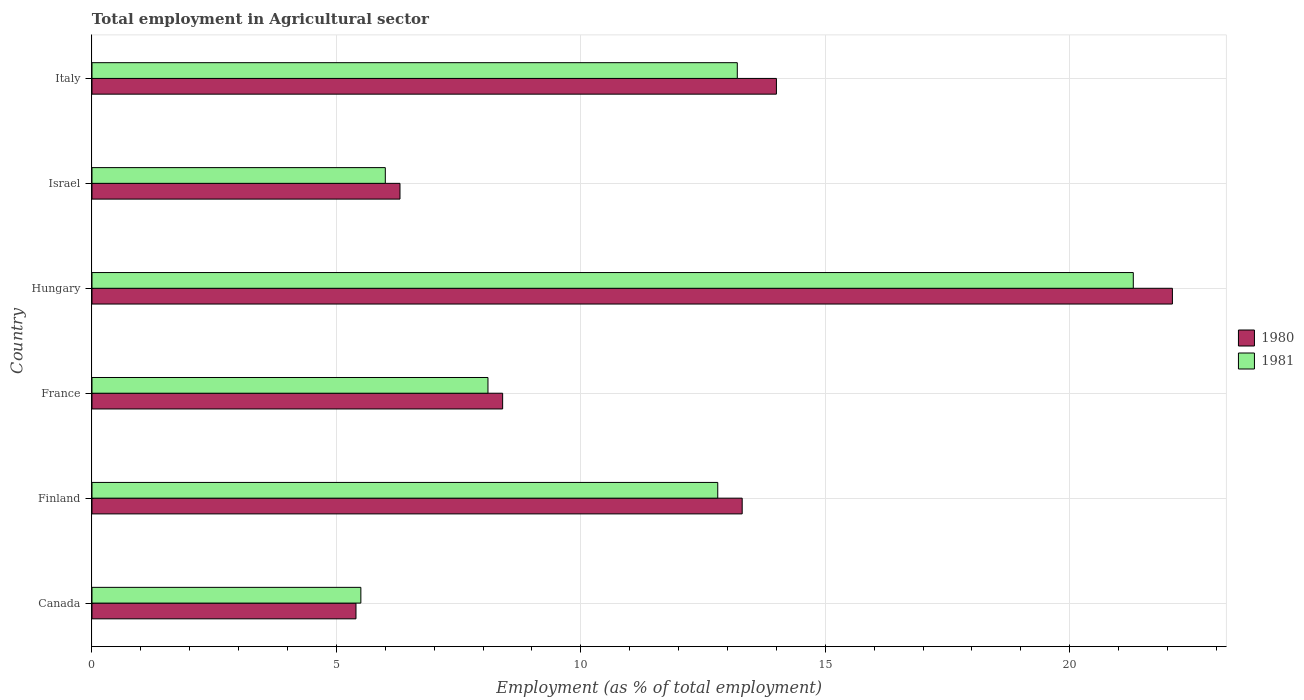How many different coloured bars are there?
Keep it short and to the point. 2. How many groups of bars are there?
Offer a terse response. 6. Are the number of bars on each tick of the Y-axis equal?
Provide a short and direct response. Yes. How many bars are there on the 1st tick from the top?
Ensure brevity in your answer.  2. How many bars are there on the 6th tick from the bottom?
Make the answer very short. 2. Across all countries, what is the maximum employment in agricultural sector in 1981?
Your answer should be compact. 21.3. Across all countries, what is the minimum employment in agricultural sector in 1981?
Your response must be concise. 5.5. In which country was the employment in agricultural sector in 1980 maximum?
Provide a short and direct response. Hungary. In which country was the employment in agricultural sector in 1981 minimum?
Your answer should be compact. Canada. What is the total employment in agricultural sector in 1981 in the graph?
Offer a very short reply. 66.9. What is the difference between the employment in agricultural sector in 1981 in France and that in Hungary?
Offer a terse response. -13.2. What is the difference between the employment in agricultural sector in 1981 in Israel and the employment in agricultural sector in 1980 in France?
Provide a short and direct response. -2.4. What is the average employment in agricultural sector in 1981 per country?
Ensure brevity in your answer.  11.15. What is the difference between the employment in agricultural sector in 1981 and employment in agricultural sector in 1980 in Hungary?
Your answer should be very brief. -0.8. What is the ratio of the employment in agricultural sector in 1981 in Canada to that in France?
Offer a terse response. 0.68. Is the difference between the employment in agricultural sector in 1981 in Israel and Italy greater than the difference between the employment in agricultural sector in 1980 in Israel and Italy?
Offer a very short reply. Yes. What is the difference between the highest and the second highest employment in agricultural sector in 1981?
Offer a very short reply. 8.1. What is the difference between the highest and the lowest employment in agricultural sector in 1981?
Offer a terse response. 15.8. In how many countries, is the employment in agricultural sector in 1980 greater than the average employment in agricultural sector in 1980 taken over all countries?
Make the answer very short. 3. Is the sum of the employment in agricultural sector in 1981 in Finland and Italy greater than the maximum employment in agricultural sector in 1980 across all countries?
Give a very brief answer. Yes. What does the 2nd bar from the bottom in Italy represents?
Offer a very short reply. 1981. Are all the bars in the graph horizontal?
Provide a succinct answer. Yes. Are the values on the major ticks of X-axis written in scientific E-notation?
Keep it short and to the point. No. Does the graph contain grids?
Provide a succinct answer. Yes. How many legend labels are there?
Your response must be concise. 2. What is the title of the graph?
Offer a very short reply. Total employment in Agricultural sector. Does "1999" appear as one of the legend labels in the graph?
Provide a short and direct response. No. What is the label or title of the X-axis?
Give a very brief answer. Employment (as % of total employment). What is the label or title of the Y-axis?
Ensure brevity in your answer.  Country. What is the Employment (as % of total employment) of 1980 in Canada?
Provide a short and direct response. 5.4. What is the Employment (as % of total employment) of 1980 in Finland?
Give a very brief answer. 13.3. What is the Employment (as % of total employment) in 1981 in Finland?
Your answer should be very brief. 12.8. What is the Employment (as % of total employment) in 1980 in France?
Provide a short and direct response. 8.4. What is the Employment (as % of total employment) in 1981 in France?
Your answer should be compact. 8.1. What is the Employment (as % of total employment) in 1980 in Hungary?
Provide a succinct answer. 22.1. What is the Employment (as % of total employment) of 1981 in Hungary?
Your answer should be very brief. 21.3. What is the Employment (as % of total employment) in 1980 in Israel?
Your answer should be compact. 6.3. What is the Employment (as % of total employment) of 1981 in Israel?
Give a very brief answer. 6. What is the Employment (as % of total employment) in 1981 in Italy?
Make the answer very short. 13.2. Across all countries, what is the maximum Employment (as % of total employment) in 1980?
Your answer should be compact. 22.1. Across all countries, what is the maximum Employment (as % of total employment) in 1981?
Provide a short and direct response. 21.3. Across all countries, what is the minimum Employment (as % of total employment) of 1980?
Keep it short and to the point. 5.4. What is the total Employment (as % of total employment) of 1980 in the graph?
Offer a very short reply. 69.5. What is the total Employment (as % of total employment) of 1981 in the graph?
Offer a terse response. 66.9. What is the difference between the Employment (as % of total employment) of 1980 in Canada and that in Finland?
Keep it short and to the point. -7.9. What is the difference between the Employment (as % of total employment) in 1981 in Canada and that in Finland?
Your response must be concise. -7.3. What is the difference between the Employment (as % of total employment) in 1980 in Canada and that in Hungary?
Your answer should be very brief. -16.7. What is the difference between the Employment (as % of total employment) of 1981 in Canada and that in Hungary?
Provide a short and direct response. -15.8. What is the difference between the Employment (as % of total employment) of 1980 in Canada and that in Israel?
Offer a terse response. -0.9. What is the difference between the Employment (as % of total employment) in 1981 in Canada and that in Israel?
Provide a succinct answer. -0.5. What is the difference between the Employment (as % of total employment) of 1980 in Canada and that in Italy?
Offer a terse response. -8.6. What is the difference between the Employment (as % of total employment) of 1981 in Canada and that in Italy?
Provide a succinct answer. -7.7. What is the difference between the Employment (as % of total employment) in 1980 in Finland and that in France?
Keep it short and to the point. 4.9. What is the difference between the Employment (as % of total employment) of 1981 in Finland and that in France?
Give a very brief answer. 4.7. What is the difference between the Employment (as % of total employment) in 1981 in Finland and that in Hungary?
Ensure brevity in your answer.  -8.5. What is the difference between the Employment (as % of total employment) in 1981 in Finland and that in Israel?
Provide a short and direct response. 6.8. What is the difference between the Employment (as % of total employment) of 1980 in Finland and that in Italy?
Keep it short and to the point. -0.7. What is the difference between the Employment (as % of total employment) in 1981 in Finland and that in Italy?
Give a very brief answer. -0.4. What is the difference between the Employment (as % of total employment) of 1980 in France and that in Hungary?
Make the answer very short. -13.7. What is the difference between the Employment (as % of total employment) of 1981 in France and that in Hungary?
Your answer should be very brief. -13.2. What is the difference between the Employment (as % of total employment) in 1980 in France and that in Israel?
Provide a short and direct response. 2.1. What is the difference between the Employment (as % of total employment) in 1981 in France and that in Israel?
Keep it short and to the point. 2.1. What is the difference between the Employment (as % of total employment) of 1980 in France and that in Italy?
Make the answer very short. -5.6. What is the difference between the Employment (as % of total employment) in 1981 in Hungary and that in Israel?
Offer a very short reply. 15.3. What is the difference between the Employment (as % of total employment) of 1980 in Hungary and that in Italy?
Your answer should be compact. 8.1. What is the difference between the Employment (as % of total employment) in 1981 in Hungary and that in Italy?
Make the answer very short. 8.1. What is the difference between the Employment (as % of total employment) of 1980 in Israel and that in Italy?
Offer a very short reply. -7.7. What is the difference between the Employment (as % of total employment) in 1980 in Canada and the Employment (as % of total employment) in 1981 in Finland?
Offer a very short reply. -7.4. What is the difference between the Employment (as % of total employment) in 1980 in Canada and the Employment (as % of total employment) in 1981 in Hungary?
Give a very brief answer. -15.9. What is the difference between the Employment (as % of total employment) of 1980 in Canada and the Employment (as % of total employment) of 1981 in Israel?
Ensure brevity in your answer.  -0.6. What is the difference between the Employment (as % of total employment) of 1980 in Canada and the Employment (as % of total employment) of 1981 in Italy?
Keep it short and to the point. -7.8. What is the difference between the Employment (as % of total employment) of 1980 in Finland and the Employment (as % of total employment) of 1981 in Hungary?
Your response must be concise. -8. What is the difference between the Employment (as % of total employment) in 1980 in Hungary and the Employment (as % of total employment) in 1981 in Israel?
Ensure brevity in your answer.  16.1. What is the difference between the Employment (as % of total employment) in 1980 in Hungary and the Employment (as % of total employment) in 1981 in Italy?
Keep it short and to the point. 8.9. What is the difference between the Employment (as % of total employment) in 1980 in Israel and the Employment (as % of total employment) in 1981 in Italy?
Offer a very short reply. -6.9. What is the average Employment (as % of total employment) in 1980 per country?
Your answer should be compact. 11.58. What is the average Employment (as % of total employment) in 1981 per country?
Give a very brief answer. 11.15. What is the difference between the Employment (as % of total employment) in 1980 and Employment (as % of total employment) in 1981 in Canada?
Keep it short and to the point. -0.1. What is the difference between the Employment (as % of total employment) in 1980 and Employment (as % of total employment) in 1981 in Hungary?
Your answer should be very brief. 0.8. What is the difference between the Employment (as % of total employment) of 1980 and Employment (as % of total employment) of 1981 in Israel?
Offer a very short reply. 0.3. What is the difference between the Employment (as % of total employment) of 1980 and Employment (as % of total employment) of 1981 in Italy?
Your answer should be very brief. 0.8. What is the ratio of the Employment (as % of total employment) of 1980 in Canada to that in Finland?
Your response must be concise. 0.41. What is the ratio of the Employment (as % of total employment) of 1981 in Canada to that in Finland?
Provide a short and direct response. 0.43. What is the ratio of the Employment (as % of total employment) of 1980 in Canada to that in France?
Provide a succinct answer. 0.64. What is the ratio of the Employment (as % of total employment) in 1981 in Canada to that in France?
Your response must be concise. 0.68. What is the ratio of the Employment (as % of total employment) in 1980 in Canada to that in Hungary?
Your answer should be very brief. 0.24. What is the ratio of the Employment (as % of total employment) of 1981 in Canada to that in Hungary?
Provide a short and direct response. 0.26. What is the ratio of the Employment (as % of total employment) of 1981 in Canada to that in Israel?
Give a very brief answer. 0.92. What is the ratio of the Employment (as % of total employment) in 1980 in Canada to that in Italy?
Give a very brief answer. 0.39. What is the ratio of the Employment (as % of total employment) in 1981 in Canada to that in Italy?
Provide a succinct answer. 0.42. What is the ratio of the Employment (as % of total employment) of 1980 in Finland to that in France?
Give a very brief answer. 1.58. What is the ratio of the Employment (as % of total employment) of 1981 in Finland to that in France?
Make the answer very short. 1.58. What is the ratio of the Employment (as % of total employment) in 1980 in Finland to that in Hungary?
Your answer should be very brief. 0.6. What is the ratio of the Employment (as % of total employment) in 1981 in Finland to that in Hungary?
Your answer should be very brief. 0.6. What is the ratio of the Employment (as % of total employment) of 1980 in Finland to that in Israel?
Provide a succinct answer. 2.11. What is the ratio of the Employment (as % of total employment) of 1981 in Finland to that in Israel?
Offer a terse response. 2.13. What is the ratio of the Employment (as % of total employment) of 1981 in Finland to that in Italy?
Provide a short and direct response. 0.97. What is the ratio of the Employment (as % of total employment) of 1980 in France to that in Hungary?
Your answer should be compact. 0.38. What is the ratio of the Employment (as % of total employment) of 1981 in France to that in Hungary?
Provide a succinct answer. 0.38. What is the ratio of the Employment (as % of total employment) in 1981 in France to that in Israel?
Offer a very short reply. 1.35. What is the ratio of the Employment (as % of total employment) of 1981 in France to that in Italy?
Make the answer very short. 0.61. What is the ratio of the Employment (as % of total employment) in 1980 in Hungary to that in Israel?
Your response must be concise. 3.51. What is the ratio of the Employment (as % of total employment) of 1981 in Hungary to that in Israel?
Provide a short and direct response. 3.55. What is the ratio of the Employment (as % of total employment) in 1980 in Hungary to that in Italy?
Offer a terse response. 1.58. What is the ratio of the Employment (as % of total employment) in 1981 in Hungary to that in Italy?
Your response must be concise. 1.61. What is the ratio of the Employment (as % of total employment) in 1980 in Israel to that in Italy?
Offer a terse response. 0.45. What is the ratio of the Employment (as % of total employment) of 1981 in Israel to that in Italy?
Give a very brief answer. 0.45. What is the difference between the highest and the second highest Employment (as % of total employment) of 1980?
Your response must be concise. 8.1. What is the difference between the highest and the lowest Employment (as % of total employment) of 1981?
Give a very brief answer. 15.8. 